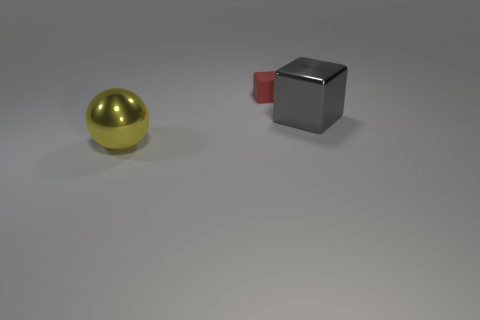Is there any other thing that has the same material as the large yellow thing?
Make the answer very short. Yes. How many other objects are there of the same shape as the tiny thing?
Make the answer very short. 1. Do the big ball and the large shiny block have the same color?
Give a very brief answer. No. The object that is on the left side of the big gray cube and in front of the small red rubber thing is made of what material?
Give a very brief answer. Metal. What is the size of the rubber cube?
Ensure brevity in your answer.  Small. What number of metallic spheres are in front of the large metal thing in front of the block right of the rubber cube?
Offer a terse response. 0. What is the shape of the metallic object that is to the left of the big metal thing that is to the right of the red object?
Offer a very short reply. Sphere. What size is the gray shiny object that is the same shape as the red object?
Your answer should be very brief. Large. Are there any other things that have the same size as the ball?
Your response must be concise. Yes. What is the color of the large object that is to the left of the big gray metal cube?
Your response must be concise. Yellow. 